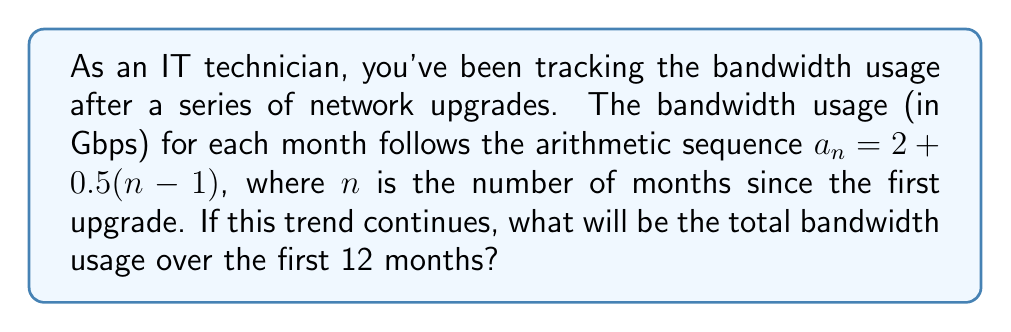Show me your answer to this math problem. Let's approach this step-by-step:

1) The given arithmetic sequence is $a_n = 2 + 0.5(n-1)$, where $a_n$ is the bandwidth usage in Gbps for the $n$th month.

2) We need to find the sum of this sequence for the first 12 months. The formula for the sum of an arithmetic sequence is:

   $$S_n = \frac{n}{2}(a_1 + a_n)$$

   where $S_n$ is the sum of $n$ terms, $a_1$ is the first term, and $a_n$ is the $n$th term.

3) We know $n = 12$ and $a_1 = 2$ (when $n = 1$).

4) To find $a_{12}$, we substitute $n = 12$ into the original sequence formula:
   
   $a_{12} = 2 + 0.5(12-1) = 2 + 0.5(11) = 2 + 5.5 = 7.5$

5) Now we can substitute these values into the sum formula:

   $$S_{12} = \frac{12}{2}(2 + 7.5) = 6(9.5) = 57$$

Therefore, the total bandwidth usage over the first 12 months will be 57 Gbps.
Answer: 57 Gbps 